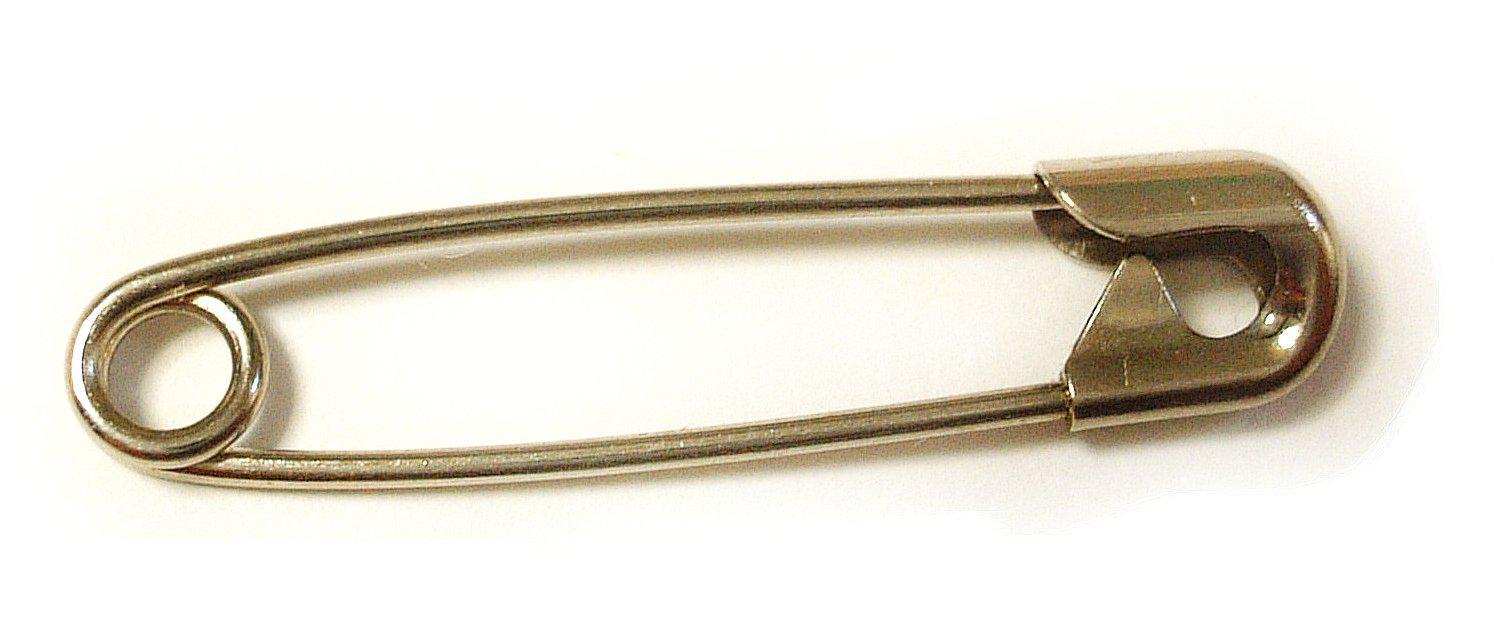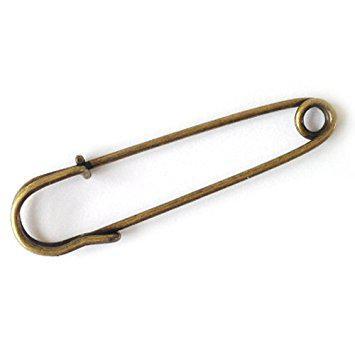The first image is the image on the left, the second image is the image on the right. Evaluate the accuracy of this statement regarding the images: "The left image contains no more than one gold safety pin.". Is it true? Answer yes or no. Yes. The first image is the image on the left, the second image is the image on the right. For the images displayed, is the sentence "One pin in the image on the right is open." factually correct? Answer yes or no. No. 